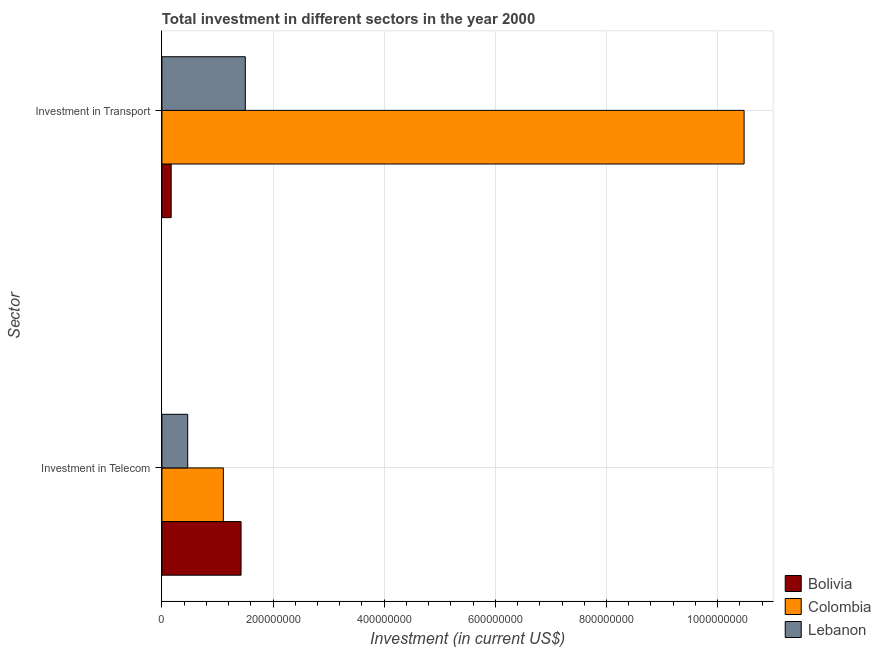How many different coloured bars are there?
Offer a very short reply. 3. How many groups of bars are there?
Ensure brevity in your answer.  2. How many bars are there on the 2nd tick from the top?
Offer a very short reply. 3. How many bars are there on the 1st tick from the bottom?
Keep it short and to the point. 3. What is the label of the 1st group of bars from the top?
Give a very brief answer. Investment in Transport. What is the investment in transport in Colombia?
Keep it short and to the point. 1.05e+09. Across all countries, what is the maximum investment in transport?
Your response must be concise. 1.05e+09. Across all countries, what is the minimum investment in transport?
Offer a very short reply. 1.66e+07. In which country was the investment in telecom minimum?
Provide a short and direct response. Lebanon. What is the total investment in transport in the graph?
Ensure brevity in your answer.  1.21e+09. What is the difference between the investment in transport in Bolivia and that in Colombia?
Provide a succinct answer. -1.03e+09. What is the difference between the investment in telecom in Bolivia and the investment in transport in Lebanon?
Your response must be concise. -7.60e+06. What is the average investment in telecom per country?
Give a very brief answer. 9.98e+07. What is the difference between the investment in transport and investment in telecom in Bolivia?
Provide a succinct answer. -1.26e+08. What is the ratio of the investment in telecom in Colombia to that in Bolivia?
Your answer should be very brief. 0.78. What does the 2nd bar from the top in Investment in Telecom represents?
Ensure brevity in your answer.  Colombia. What does the 2nd bar from the bottom in Investment in Telecom represents?
Your response must be concise. Colombia. What is the difference between two consecutive major ticks on the X-axis?
Give a very brief answer. 2.00e+08. Does the graph contain any zero values?
Provide a short and direct response. No. How are the legend labels stacked?
Your answer should be compact. Vertical. What is the title of the graph?
Keep it short and to the point. Total investment in different sectors in the year 2000. What is the label or title of the X-axis?
Offer a terse response. Investment (in current US$). What is the label or title of the Y-axis?
Make the answer very short. Sector. What is the Investment (in current US$) of Bolivia in Investment in Telecom?
Keep it short and to the point. 1.42e+08. What is the Investment (in current US$) of Colombia in Investment in Telecom?
Give a very brief answer. 1.10e+08. What is the Investment (in current US$) of Lebanon in Investment in Telecom?
Provide a succinct answer. 4.64e+07. What is the Investment (in current US$) in Bolivia in Investment in Transport?
Provide a succinct answer. 1.66e+07. What is the Investment (in current US$) of Colombia in Investment in Transport?
Provide a succinct answer. 1.05e+09. What is the Investment (in current US$) in Lebanon in Investment in Transport?
Provide a short and direct response. 1.50e+08. Across all Sector, what is the maximum Investment (in current US$) in Bolivia?
Provide a succinct answer. 1.42e+08. Across all Sector, what is the maximum Investment (in current US$) in Colombia?
Provide a short and direct response. 1.05e+09. Across all Sector, what is the maximum Investment (in current US$) in Lebanon?
Offer a terse response. 1.50e+08. Across all Sector, what is the minimum Investment (in current US$) in Bolivia?
Provide a succinct answer. 1.66e+07. Across all Sector, what is the minimum Investment (in current US$) in Colombia?
Offer a terse response. 1.10e+08. Across all Sector, what is the minimum Investment (in current US$) in Lebanon?
Your response must be concise. 4.64e+07. What is the total Investment (in current US$) in Bolivia in the graph?
Provide a succinct answer. 1.59e+08. What is the total Investment (in current US$) of Colombia in the graph?
Make the answer very short. 1.16e+09. What is the total Investment (in current US$) of Lebanon in the graph?
Offer a terse response. 1.96e+08. What is the difference between the Investment (in current US$) of Bolivia in Investment in Telecom and that in Investment in Transport?
Provide a short and direct response. 1.26e+08. What is the difference between the Investment (in current US$) in Colombia in Investment in Telecom and that in Investment in Transport?
Your response must be concise. -9.37e+08. What is the difference between the Investment (in current US$) in Lebanon in Investment in Telecom and that in Investment in Transport?
Keep it short and to the point. -1.04e+08. What is the difference between the Investment (in current US$) in Bolivia in Investment in Telecom and the Investment (in current US$) in Colombia in Investment in Transport?
Provide a short and direct response. -9.05e+08. What is the difference between the Investment (in current US$) in Bolivia in Investment in Telecom and the Investment (in current US$) in Lebanon in Investment in Transport?
Offer a very short reply. -7.60e+06. What is the difference between the Investment (in current US$) of Colombia in Investment in Telecom and the Investment (in current US$) of Lebanon in Investment in Transport?
Offer a terse response. -3.95e+07. What is the average Investment (in current US$) of Bolivia per Sector?
Your answer should be very brief. 7.95e+07. What is the average Investment (in current US$) of Colombia per Sector?
Your answer should be very brief. 5.79e+08. What is the average Investment (in current US$) in Lebanon per Sector?
Give a very brief answer. 9.82e+07. What is the difference between the Investment (in current US$) of Bolivia and Investment (in current US$) of Colombia in Investment in Telecom?
Offer a terse response. 3.19e+07. What is the difference between the Investment (in current US$) in Bolivia and Investment (in current US$) in Lebanon in Investment in Telecom?
Provide a succinct answer. 9.60e+07. What is the difference between the Investment (in current US$) of Colombia and Investment (in current US$) of Lebanon in Investment in Telecom?
Your answer should be very brief. 6.41e+07. What is the difference between the Investment (in current US$) in Bolivia and Investment (in current US$) in Colombia in Investment in Transport?
Your answer should be very brief. -1.03e+09. What is the difference between the Investment (in current US$) of Bolivia and Investment (in current US$) of Lebanon in Investment in Transport?
Make the answer very short. -1.33e+08. What is the difference between the Investment (in current US$) in Colombia and Investment (in current US$) in Lebanon in Investment in Transport?
Your response must be concise. 8.98e+08. What is the ratio of the Investment (in current US$) of Bolivia in Investment in Telecom to that in Investment in Transport?
Give a very brief answer. 8.58. What is the ratio of the Investment (in current US$) of Colombia in Investment in Telecom to that in Investment in Transport?
Your response must be concise. 0.11. What is the ratio of the Investment (in current US$) in Lebanon in Investment in Telecom to that in Investment in Transport?
Provide a short and direct response. 0.31. What is the difference between the highest and the second highest Investment (in current US$) of Bolivia?
Keep it short and to the point. 1.26e+08. What is the difference between the highest and the second highest Investment (in current US$) of Colombia?
Your response must be concise. 9.37e+08. What is the difference between the highest and the second highest Investment (in current US$) of Lebanon?
Offer a very short reply. 1.04e+08. What is the difference between the highest and the lowest Investment (in current US$) of Bolivia?
Ensure brevity in your answer.  1.26e+08. What is the difference between the highest and the lowest Investment (in current US$) of Colombia?
Offer a very short reply. 9.37e+08. What is the difference between the highest and the lowest Investment (in current US$) of Lebanon?
Ensure brevity in your answer.  1.04e+08. 